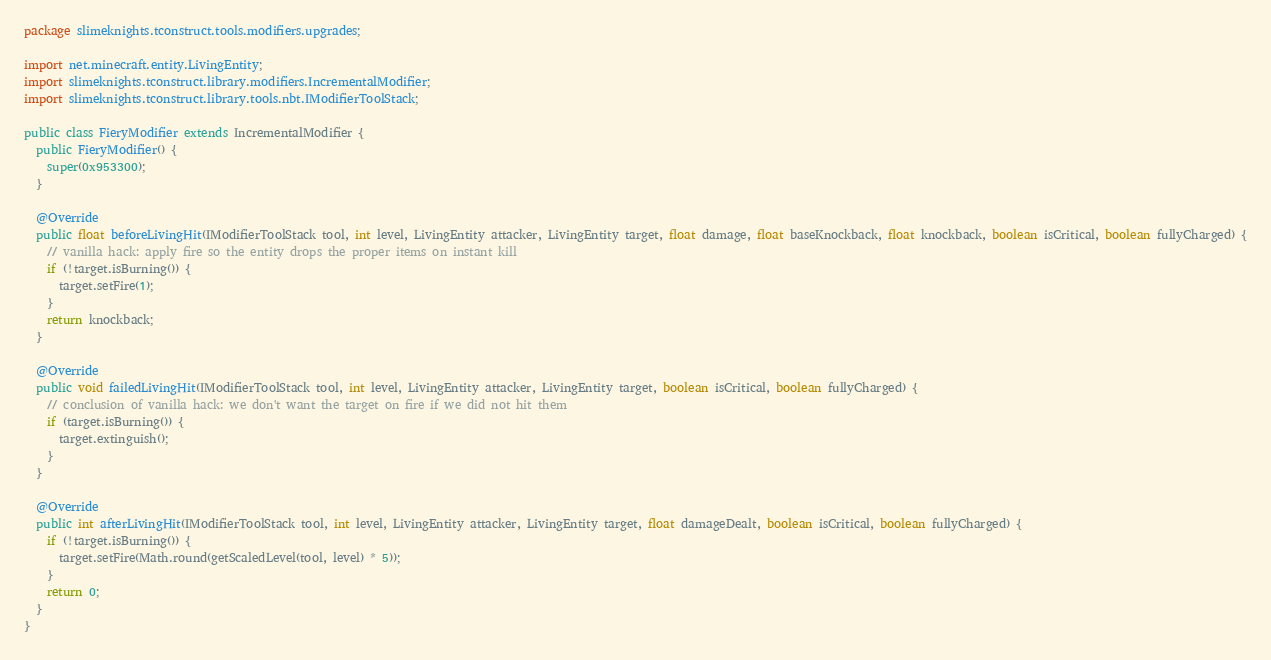Convert code to text. <code><loc_0><loc_0><loc_500><loc_500><_Java_>package slimeknights.tconstruct.tools.modifiers.upgrades;

import net.minecraft.entity.LivingEntity;
import slimeknights.tconstruct.library.modifiers.IncrementalModifier;
import slimeknights.tconstruct.library.tools.nbt.IModifierToolStack;

public class FieryModifier extends IncrementalModifier {
  public FieryModifier() {
    super(0x953300);
  }

  @Override
  public float beforeLivingHit(IModifierToolStack tool, int level, LivingEntity attacker, LivingEntity target, float damage, float baseKnockback, float knockback, boolean isCritical, boolean fullyCharged) {
    // vanilla hack: apply fire so the entity drops the proper items on instant kill
    if (!target.isBurning()) {
      target.setFire(1);
    }
    return knockback;
  }

  @Override
  public void failedLivingHit(IModifierToolStack tool, int level, LivingEntity attacker, LivingEntity target, boolean isCritical, boolean fullyCharged) {
    // conclusion of vanilla hack: we don't want the target on fire if we did not hit them
    if (target.isBurning()) {
      target.extinguish();
    }
  }

  @Override
  public int afterLivingHit(IModifierToolStack tool, int level, LivingEntity attacker, LivingEntity target, float damageDealt, boolean isCritical, boolean fullyCharged) {
    if (!target.isBurning()) {
      target.setFire(Math.round(getScaledLevel(tool, level) * 5));
    }
    return 0;
  }
}
</code> 